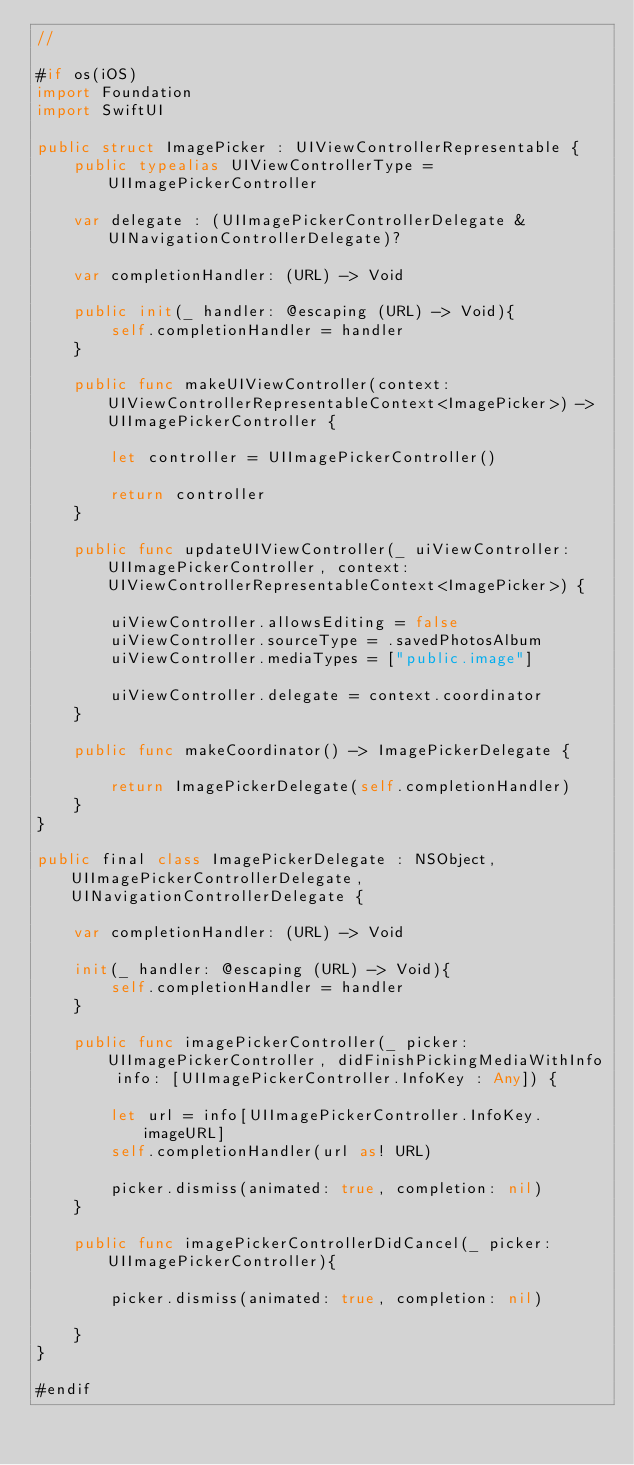<code> <loc_0><loc_0><loc_500><loc_500><_Swift_>//

#if os(iOS)
import Foundation
import SwiftUI

public struct ImagePicker : UIViewControllerRepresentable {
    public typealias UIViewControllerType = UIImagePickerController
    
    var delegate : (UIImagePickerControllerDelegate & UINavigationControllerDelegate)?
    
    var completionHandler: (URL) -> Void
    
    public init(_ handler: @escaping (URL) -> Void){
        self.completionHandler = handler
    }
    
    public func makeUIViewController(context: UIViewControllerRepresentableContext<ImagePicker>) -> UIImagePickerController {
        
        let controller = UIImagePickerController()
        
        return controller
    }
    
    public func updateUIViewController(_ uiViewController: UIImagePickerController, context: UIViewControllerRepresentableContext<ImagePicker>) {
        
        uiViewController.allowsEditing = false
        uiViewController.sourceType = .savedPhotosAlbum
        uiViewController.mediaTypes = ["public.image"]
        
        uiViewController.delegate = context.coordinator
    }

    public func makeCoordinator() -> ImagePickerDelegate {
    
        return ImagePickerDelegate(self.completionHandler)
    }
}

public final class ImagePickerDelegate : NSObject, UIImagePickerControllerDelegate, UINavigationControllerDelegate {
    
    var completionHandler: (URL) -> Void
    
    init(_ handler: @escaping (URL) -> Void){
        self.completionHandler = handler
    }
    
    public func imagePickerController(_ picker: UIImagePickerController, didFinishPickingMediaWithInfo info: [UIImagePickerController.InfoKey : Any]) {
        
        let url = info[UIImagePickerController.InfoKey.imageURL]
        self.completionHandler(url as! URL)
        
        picker.dismiss(animated: true, completion: nil)
    }
    
    public func imagePickerControllerDidCancel(_ picker: UIImagePickerController){
        
        picker.dismiss(animated: true, completion: nil)
        
    }
}

#endif
</code> 